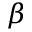Convert formula to latex. <formula><loc_0><loc_0><loc_500><loc_500>\beta</formula> 